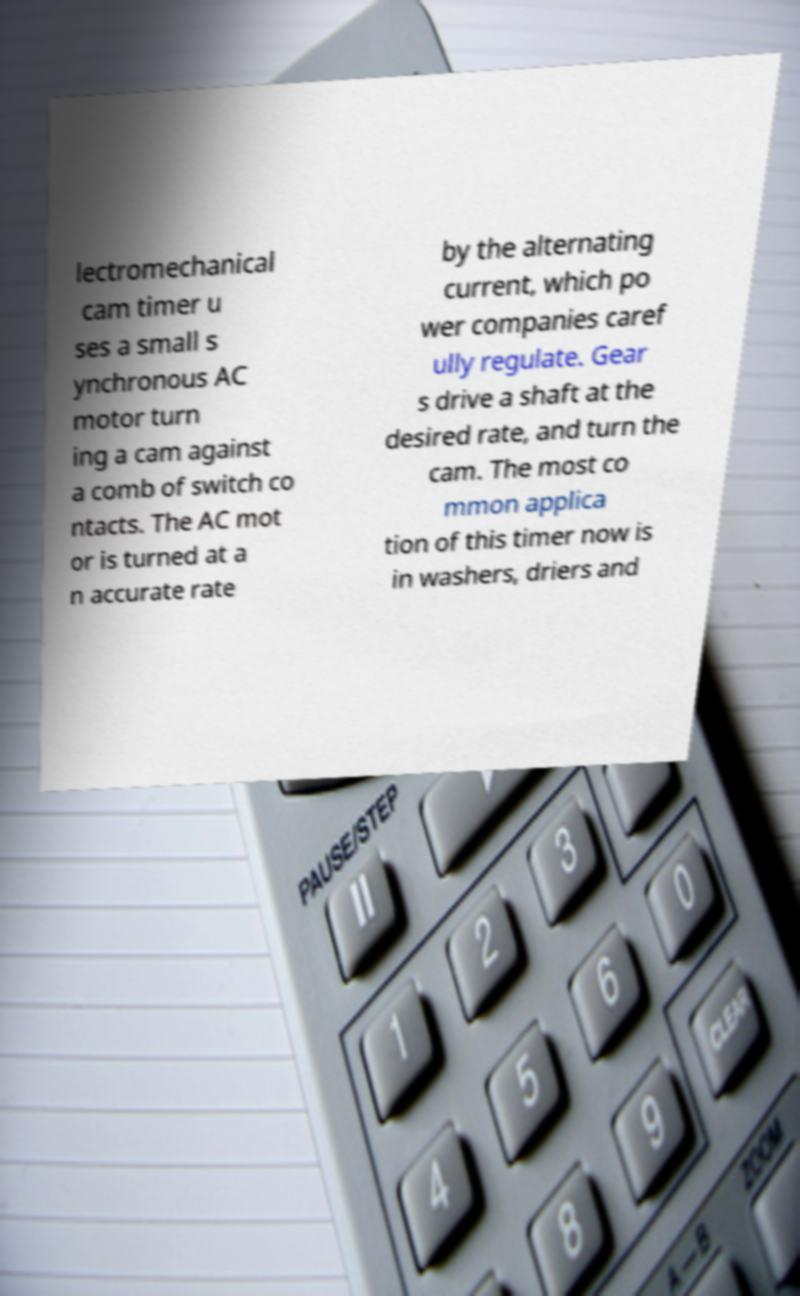Please read and relay the text visible in this image. What does it say? lectromechanical cam timer u ses a small s ynchronous AC motor turn ing a cam against a comb of switch co ntacts. The AC mot or is turned at a n accurate rate by the alternating current, which po wer companies caref ully regulate. Gear s drive a shaft at the desired rate, and turn the cam. The most co mmon applica tion of this timer now is in washers, driers and 